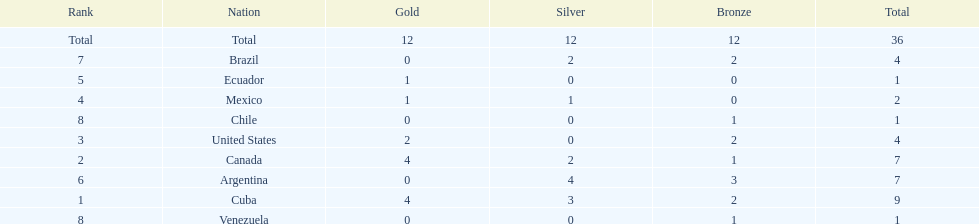Which country won the largest haul of bronze medals? Argentina. 